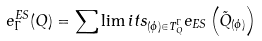<formula> <loc_0><loc_0><loc_500><loc_500>e _ { \Gamma } ^ { E S } ( Q ) = \sum \lim i t s _ { ( \phi ) \in T _ { Q } ^ { \Gamma } } e _ { E S } \left ( \tilde { Q } _ { ( \phi ) } \right )</formula> 